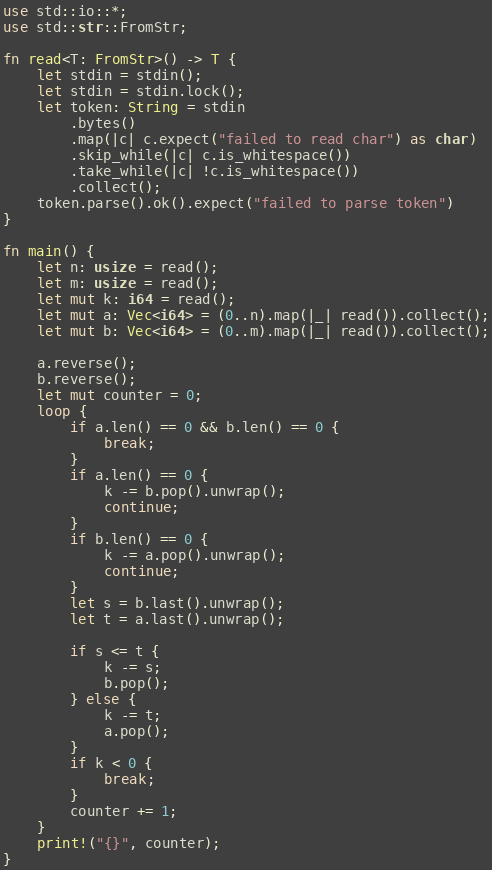<code> <loc_0><loc_0><loc_500><loc_500><_Rust_>use std::io::*;
use std::str::FromStr;

fn read<T: FromStr>() -> T {
    let stdin = stdin();
    let stdin = stdin.lock();
    let token: String = stdin
        .bytes()
        .map(|c| c.expect("failed to read char") as char)
        .skip_while(|c| c.is_whitespace())
        .take_while(|c| !c.is_whitespace())
        .collect();
    token.parse().ok().expect("failed to parse token")
}

fn main() {
    let n: usize = read();
    let m: usize = read();
    let mut k: i64 = read();
    let mut a: Vec<i64> = (0..n).map(|_| read()).collect();
    let mut b: Vec<i64> = (0..m).map(|_| read()).collect();

    a.reverse();
    b.reverse();
    let mut counter = 0;
    loop {
        if a.len() == 0 && b.len() == 0 {
            break;
        }
        if a.len() == 0 {
            k -= b.pop().unwrap();
            continue;
        }
        if b.len() == 0 {
            k -= a.pop().unwrap();
            continue;
        }
        let s = b.last().unwrap();
        let t = a.last().unwrap();

        if s <= t {
            k -= s;
            b.pop();
        } else {
            k -= t;
            a.pop();
        }
        if k < 0 {
            break;
        }
        counter += 1;
    }
    print!("{}", counter);
}
</code> 